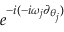<formula> <loc_0><loc_0><loc_500><loc_500>e ^ { - i ( - i \omega _ { j } \partial _ { \theta _ { j } } ) }</formula> 